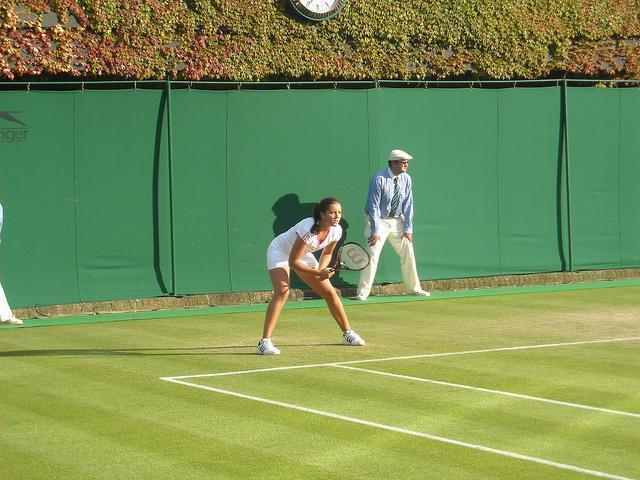Which shadow is the longest?
Pick the correct solution from the four options below to address the question.
Options: Pole, tennis racket, woman, man. Woman. 